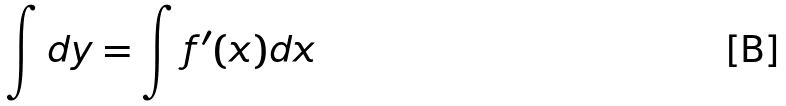Convert formula to latex. <formula><loc_0><loc_0><loc_500><loc_500>\int d y = \int f ^ { \prime } ( x ) d x</formula> 